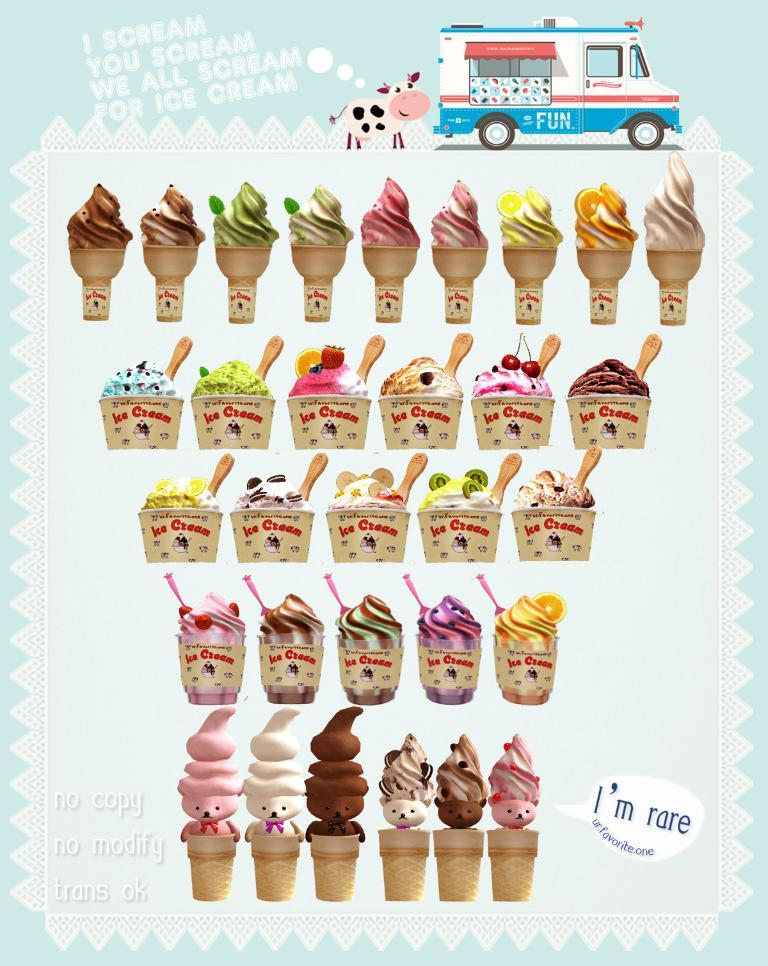What is the main subject of the image? The main subject of the image is ice creams. Can you describe any other elements in the image? Yes, there is a van visible at the top of the image. What type of button can be seen on the wire in the image? There is no button or wire present in the image. How many cents are visible in the image? There is no reference to currency or cents in the image. 